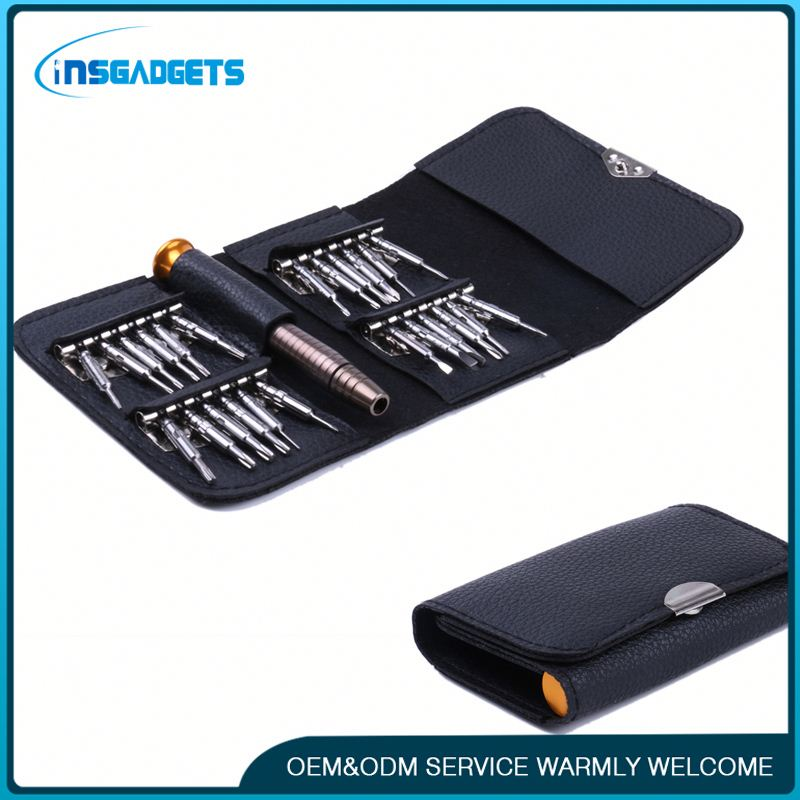Describe a realistic scenario where this tool set is incredibly useful. A common scenario where this precision screwdriver set proves incredibly useful is during smartphone repair. Imagine you accidentally drop your phone, and the screen cracks. With no immediate access to a professional repair service, you decide to fix it yourself. This toolkit comes to the rescue with its variety of precision bits, perfect for opening the phone casing, carefully removing delicate components, and replacing the damaged screen with a new one. The organized case ensures you have all the necessary tools at your disposal, making the repair process smooth and efficient. How might this toolkit benefit someone working on an intricate model? For someone working on an intricate model, such as a detailed scale model of a spaceship or a historical replica, precision tools are indispensable. This INSGADGETS Precision Screwdriver Set would be perfect for assembling and disassembling small parts without causing damage. The variety of bits allows for versatility in handling different screw types and sizes, providing the fine control needed for delicate work. The high-quality construction of the tools ensures durability and precision, which are critical when working on such intricate projects. Additionally, the compact case keeps everything organized and easily accessible, ensuring a streamlined, enjoyable build experience. 